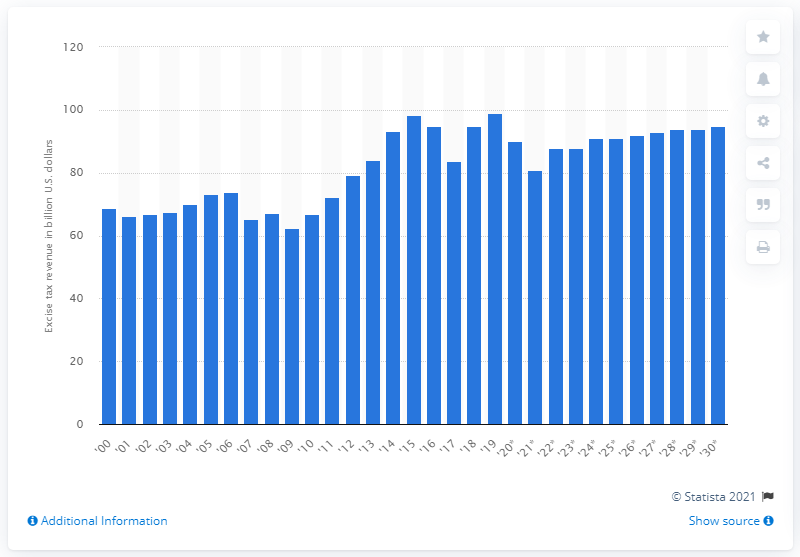List a handful of essential elements in this visual. The excise tax revenue in 2019 was approximately $99 million. The forecast predicts a decline in excise tax revenue to 81 in 2021. 